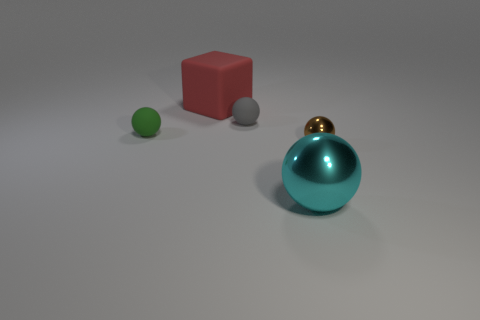Subtract 2 balls. How many balls are left? 2 Subtract all brown balls. How many balls are left? 3 Subtract all tiny balls. How many balls are left? 1 Add 1 red rubber blocks. How many objects exist? 6 Subtract all red spheres. Subtract all cyan cylinders. How many spheres are left? 4 Subtract all balls. How many objects are left? 1 Add 4 small green matte things. How many small green matte things are left? 5 Add 2 tiny gray objects. How many tiny gray objects exist? 3 Subtract 0 gray cylinders. How many objects are left? 5 Subtract all small metallic objects. Subtract all tiny matte things. How many objects are left? 2 